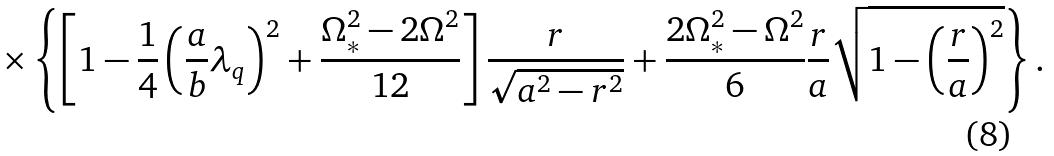<formula> <loc_0><loc_0><loc_500><loc_500>\times \left \{ \left [ 1 - \frac { 1 } { 4 } \left ( \frac { a } { b } \lambda _ { q } \right ) ^ { 2 } + \frac { \Omega _ { \ast } ^ { 2 } - 2 \Omega ^ { 2 } } { 1 2 } \right ] \frac { r } { \sqrt { a ^ { 2 } - r ^ { 2 } } } + \frac { 2 \Omega _ { \ast } ^ { 2 } - \Omega ^ { 2 } } { 6 } \frac { r } { a } \sqrt { 1 - \left ( \frac { r } { a } \right ) ^ { 2 } } \right \} .</formula> 